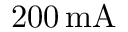<formula> <loc_0><loc_0><loc_500><loc_500>2 0 0 \, m A</formula> 